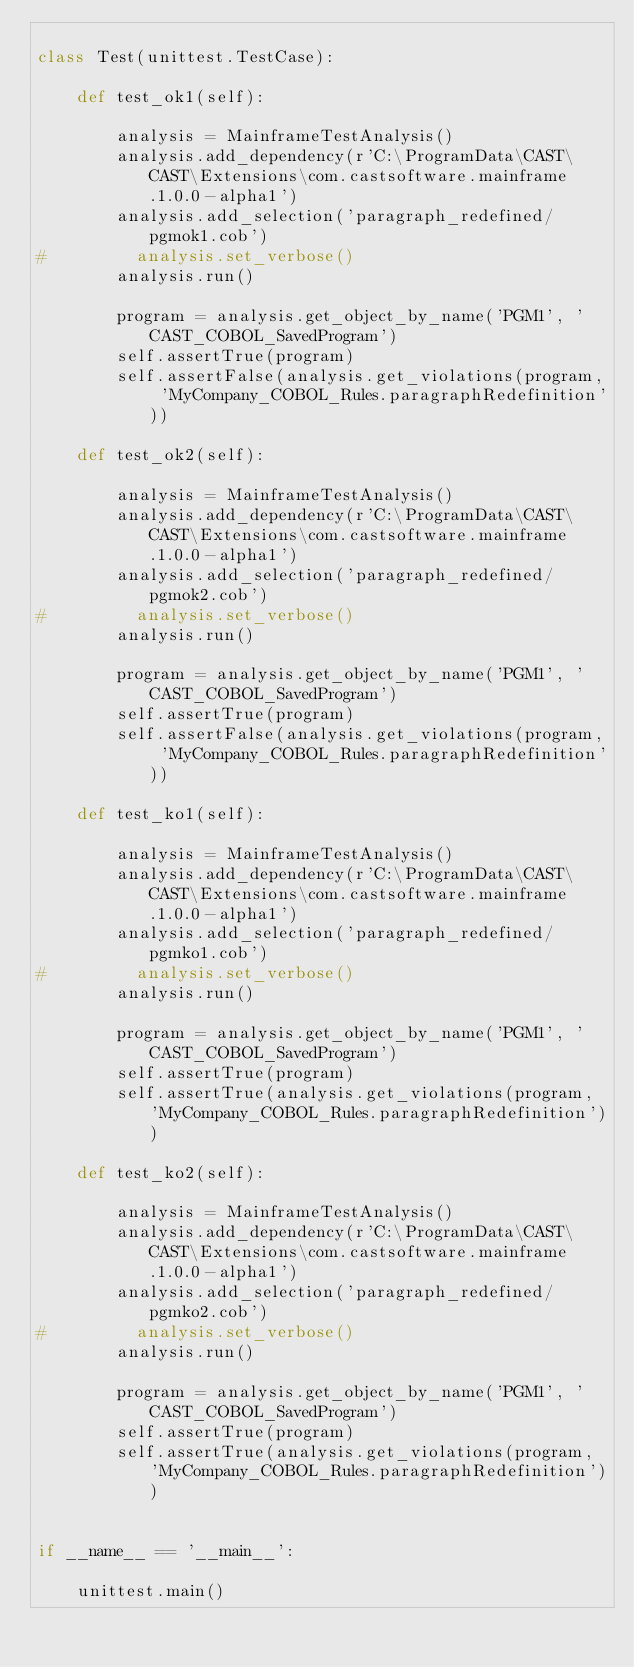Convert code to text. <code><loc_0><loc_0><loc_500><loc_500><_Python_>
class Test(unittest.TestCase):
    
    def test_ok1(self):
        
        analysis = MainframeTestAnalysis()
        analysis.add_dependency(r'C:\ProgramData\CAST\CAST\Extensions\com.castsoftware.mainframe.1.0.0-alpha1')
        analysis.add_selection('paragraph_redefined/pgmok1.cob')
#         analysis.set_verbose()
        analysis.run()
        
        program = analysis.get_object_by_name('PGM1', 'CAST_COBOL_SavedProgram')
        self.assertTrue(program)
        self.assertFalse(analysis.get_violations(program, 'MyCompany_COBOL_Rules.paragraphRedefinition'))
        
    def test_ok2(self):
        
        analysis = MainframeTestAnalysis()
        analysis.add_dependency(r'C:\ProgramData\CAST\CAST\Extensions\com.castsoftware.mainframe.1.0.0-alpha1')
        analysis.add_selection('paragraph_redefined/pgmok2.cob')
#         analysis.set_verbose()
        analysis.run()

        program = analysis.get_object_by_name('PGM1', 'CAST_COBOL_SavedProgram')
        self.assertTrue(program)
        self.assertFalse(analysis.get_violations(program, 'MyCompany_COBOL_Rules.paragraphRedefinition'))
        
    def test_ko1(self):
        
        analysis = MainframeTestAnalysis()
        analysis.add_dependency(r'C:\ProgramData\CAST\CAST\Extensions\com.castsoftware.mainframe.1.0.0-alpha1')
        analysis.add_selection('paragraph_redefined/pgmko1.cob')
#         analysis.set_verbose()
        analysis.run()
        
        program = analysis.get_object_by_name('PGM1', 'CAST_COBOL_SavedProgram')
        self.assertTrue(program)
        self.assertTrue(analysis.get_violations(program, 'MyCompany_COBOL_Rules.paragraphRedefinition'))
        
    def test_ko2(self):
        
        analysis = MainframeTestAnalysis()
        analysis.add_dependency(r'C:\ProgramData\CAST\CAST\Extensions\com.castsoftware.mainframe.1.0.0-alpha1')
        analysis.add_selection('paragraph_redefined/pgmko2.cob')
#         analysis.set_verbose()
        analysis.run()

        program = analysis.get_object_by_name('PGM1', 'CAST_COBOL_SavedProgram')
        self.assertTrue(program)
        self.assertTrue(analysis.get_violations(program, 'MyCompany_COBOL_Rules.paragraphRedefinition'))

    
if __name__ == '__main__':
    
    unittest.main()</code> 